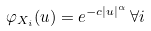Convert formula to latex. <formula><loc_0><loc_0><loc_500><loc_500>\varphi _ { X _ { i } } ( u ) = e ^ { - c | u | ^ { \alpha } } \, \forall i</formula> 